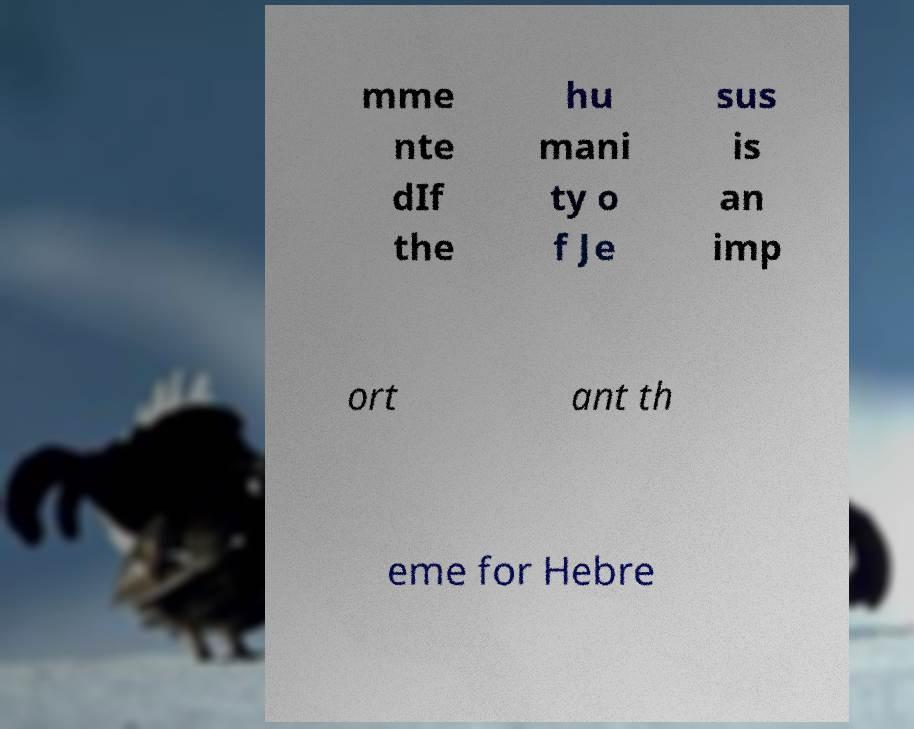What messages or text are displayed in this image? I need them in a readable, typed format. mme nte dIf the hu mani ty o f Je sus is an imp ort ant th eme for Hebre 